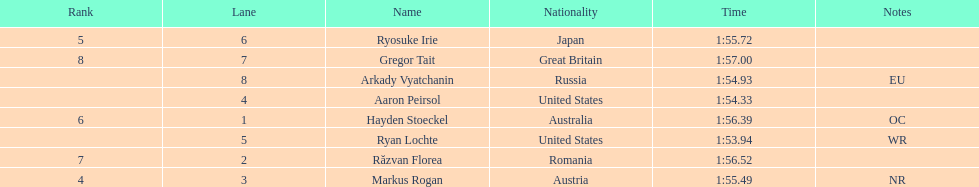Which country had the most medals in the competition? United States. 